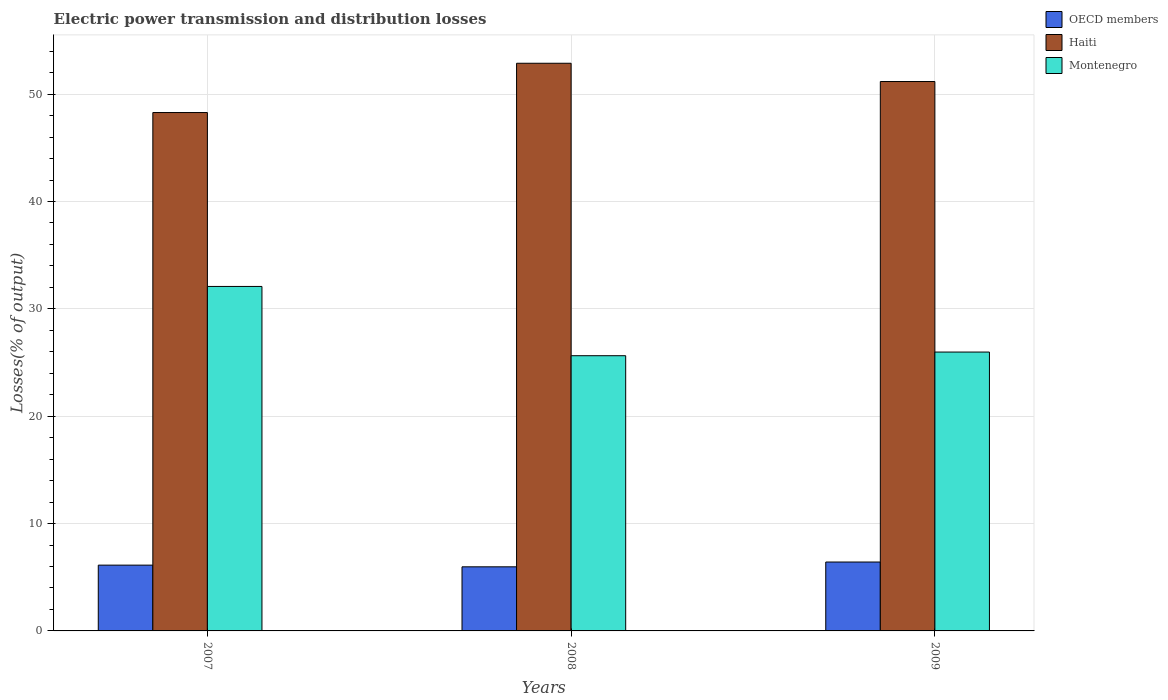How many different coloured bars are there?
Make the answer very short. 3. How many groups of bars are there?
Give a very brief answer. 3. Are the number of bars per tick equal to the number of legend labels?
Your answer should be very brief. Yes. How many bars are there on the 2nd tick from the right?
Provide a short and direct response. 3. What is the electric power transmission and distribution losses in OECD members in 2007?
Give a very brief answer. 6.13. Across all years, what is the maximum electric power transmission and distribution losses in OECD members?
Offer a very short reply. 6.42. Across all years, what is the minimum electric power transmission and distribution losses in Haiti?
Ensure brevity in your answer.  48.29. What is the total electric power transmission and distribution losses in OECD members in the graph?
Offer a terse response. 18.52. What is the difference between the electric power transmission and distribution losses in OECD members in 2007 and that in 2008?
Give a very brief answer. 0.16. What is the difference between the electric power transmission and distribution losses in OECD members in 2008 and the electric power transmission and distribution losses in Haiti in 2007?
Give a very brief answer. -42.32. What is the average electric power transmission and distribution losses in OECD members per year?
Offer a very short reply. 6.17. In the year 2007, what is the difference between the electric power transmission and distribution losses in Haiti and electric power transmission and distribution losses in Montenegro?
Offer a very short reply. 16.2. What is the ratio of the electric power transmission and distribution losses in OECD members in 2007 to that in 2008?
Offer a terse response. 1.03. Is the electric power transmission and distribution losses in Montenegro in 2008 less than that in 2009?
Give a very brief answer. Yes. Is the difference between the electric power transmission and distribution losses in Haiti in 2007 and 2008 greater than the difference between the electric power transmission and distribution losses in Montenegro in 2007 and 2008?
Your answer should be very brief. No. What is the difference between the highest and the second highest electric power transmission and distribution losses in Haiti?
Provide a succinct answer. 1.7. What is the difference between the highest and the lowest electric power transmission and distribution losses in Haiti?
Provide a succinct answer. 4.59. In how many years, is the electric power transmission and distribution losses in Haiti greater than the average electric power transmission and distribution losses in Haiti taken over all years?
Make the answer very short. 2. What does the 1st bar from the left in 2007 represents?
Offer a very short reply. OECD members. What does the 2nd bar from the right in 2007 represents?
Give a very brief answer. Haiti. Is it the case that in every year, the sum of the electric power transmission and distribution losses in Haiti and electric power transmission and distribution losses in OECD members is greater than the electric power transmission and distribution losses in Montenegro?
Your response must be concise. Yes. How many bars are there?
Your answer should be compact. 9. Are all the bars in the graph horizontal?
Ensure brevity in your answer.  No. What is the difference between two consecutive major ticks on the Y-axis?
Your response must be concise. 10. Are the values on the major ticks of Y-axis written in scientific E-notation?
Your answer should be very brief. No. Does the graph contain any zero values?
Provide a short and direct response. No. Does the graph contain grids?
Offer a terse response. Yes. How are the legend labels stacked?
Keep it short and to the point. Vertical. What is the title of the graph?
Your response must be concise. Electric power transmission and distribution losses. Does "Gambia, The" appear as one of the legend labels in the graph?
Your answer should be compact. No. What is the label or title of the X-axis?
Provide a short and direct response. Years. What is the label or title of the Y-axis?
Give a very brief answer. Losses(% of output). What is the Losses(% of output) of OECD members in 2007?
Your answer should be compact. 6.13. What is the Losses(% of output) in Haiti in 2007?
Offer a very short reply. 48.29. What is the Losses(% of output) in Montenegro in 2007?
Offer a very short reply. 32.09. What is the Losses(% of output) of OECD members in 2008?
Offer a very short reply. 5.97. What is the Losses(% of output) in Haiti in 2008?
Ensure brevity in your answer.  52.88. What is the Losses(% of output) of Montenegro in 2008?
Your answer should be compact. 25.64. What is the Losses(% of output) in OECD members in 2009?
Your answer should be compact. 6.42. What is the Losses(% of output) of Haiti in 2009?
Provide a short and direct response. 51.18. What is the Losses(% of output) of Montenegro in 2009?
Offer a terse response. 25.98. Across all years, what is the maximum Losses(% of output) of OECD members?
Your answer should be very brief. 6.42. Across all years, what is the maximum Losses(% of output) in Haiti?
Give a very brief answer. 52.88. Across all years, what is the maximum Losses(% of output) in Montenegro?
Your answer should be very brief. 32.09. Across all years, what is the minimum Losses(% of output) in OECD members?
Offer a very short reply. 5.97. Across all years, what is the minimum Losses(% of output) in Haiti?
Your response must be concise. 48.29. Across all years, what is the minimum Losses(% of output) of Montenegro?
Offer a very short reply. 25.64. What is the total Losses(% of output) in OECD members in the graph?
Offer a terse response. 18.52. What is the total Losses(% of output) in Haiti in the graph?
Give a very brief answer. 152.35. What is the total Losses(% of output) in Montenegro in the graph?
Your answer should be very brief. 83.7. What is the difference between the Losses(% of output) of OECD members in 2007 and that in 2008?
Provide a short and direct response. 0.16. What is the difference between the Losses(% of output) of Haiti in 2007 and that in 2008?
Offer a very short reply. -4.59. What is the difference between the Losses(% of output) of Montenegro in 2007 and that in 2008?
Provide a short and direct response. 6.45. What is the difference between the Losses(% of output) of OECD members in 2007 and that in 2009?
Offer a very short reply. -0.29. What is the difference between the Losses(% of output) in Haiti in 2007 and that in 2009?
Keep it short and to the point. -2.89. What is the difference between the Losses(% of output) of Montenegro in 2007 and that in 2009?
Provide a short and direct response. 6.11. What is the difference between the Losses(% of output) of OECD members in 2008 and that in 2009?
Your answer should be very brief. -0.45. What is the difference between the Losses(% of output) in Haiti in 2008 and that in 2009?
Ensure brevity in your answer.  1.7. What is the difference between the Losses(% of output) in Montenegro in 2008 and that in 2009?
Offer a very short reply. -0.34. What is the difference between the Losses(% of output) of OECD members in 2007 and the Losses(% of output) of Haiti in 2008?
Give a very brief answer. -46.75. What is the difference between the Losses(% of output) in OECD members in 2007 and the Losses(% of output) in Montenegro in 2008?
Your answer should be very brief. -19.51. What is the difference between the Losses(% of output) in Haiti in 2007 and the Losses(% of output) in Montenegro in 2008?
Make the answer very short. 22.65. What is the difference between the Losses(% of output) of OECD members in 2007 and the Losses(% of output) of Haiti in 2009?
Ensure brevity in your answer.  -45.05. What is the difference between the Losses(% of output) in OECD members in 2007 and the Losses(% of output) in Montenegro in 2009?
Give a very brief answer. -19.85. What is the difference between the Losses(% of output) of Haiti in 2007 and the Losses(% of output) of Montenegro in 2009?
Your answer should be very brief. 22.31. What is the difference between the Losses(% of output) in OECD members in 2008 and the Losses(% of output) in Haiti in 2009?
Offer a terse response. -45.21. What is the difference between the Losses(% of output) in OECD members in 2008 and the Losses(% of output) in Montenegro in 2009?
Provide a short and direct response. -20.01. What is the difference between the Losses(% of output) of Haiti in 2008 and the Losses(% of output) of Montenegro in 2009?
Ensure brevity in your answer.  26.9. What is the average Losses(% of output) of OECD members per year?
Give a very brief answer. 6.17. What is the average Losses(% of output) of Haiti per year?
Ensure brevity in your answer.  50.78. What is the average Losses(% of output) of Montenegro per year?
Provide a short and direct response. 27.9. In the year 2007, what is the difference between the Losses(% of output) of OECD members and Losses(% of output) of Haiti?
Provide a short and direct response. -42.16. In the year 2007, what is the difference between the Losses(% of output) of OECD members and Losses(% of output) of Montenegro?
Offer a terse response. -25.96. In the year 2007, what is the difference between the Losses(% of output) of Haiti and Losses(% of output) of Montenegro?
Offer a terse response. 16.2. In the year 2008, what is the difference between the Losses(% of output) in OECD members and Losses(% of output) in Haiti?
Your response must be concise. -46.91. In the year 2008, what is the difference between the Losses(% of output) of OECD members and Losses(% of output) of Montenegro?
Keep it short and to the point. -19.66. In the year 2008, what is the difference between the Losses(% of output) of Haiti and Losses(% of output) of Montenegro?
Your response must be concise. 27.24. In the year 2009, what is the difference between the Losses(% of output) of OECD members and Losses(% of output) of Haiti?
Give a very brief answer. -44.76. In the year 2009, what is the difference between the Losses(% of output) of OECD members and Losses(% of output) of Montenegro?
Your response must be concise. -19.56. In the year 2009, what is the difference between the Losses(% of output) of Haiti and Losses(% of output) of Montenegro?
Make the answer very short. 25.2. What is the ratio of the Losses(% of output) of OECD members in 2007 to that in 2008?
Your answer should be compact. 1.03. What is the ratio of the Losses(% of output) in Haiti in 2007 to that in 2008?
Offer a terse response. 0.91. What is the ratio of the Losses(% of output) in Montenegro in 2007 to that in 2008?
Offer a terse response. 1.25. What is the ratio of the Losses(% of output) in OECD members in 2007 to that in 2009?
Provide a succinct answer. 0.95. What is the ratio of the Losses(% of output) in Haiti in 2007 to that in 2009?
Give a very brief answer. 0.94. What is the ratio of the Losses(% of output) in Montenegro in 2007 to that in 2009?
Your answer should be compact. 1.24. What is the ratio of the Losses(% of output) of OECD members in 2008 to that in 2009?
Keep it short and to the point. 0.93. What is the ratio of the Losses(% of output) in Montenegro in 2008 to that in 2009?
Your answer should be very brief. 0.99. What is the difference between the highest and the second highest Losses(% of output) of OECD members?
Make the answer very short. 0.29. What is the difference between the highest and the second highest Losses(% of output) in Haiti?
Your answer should be very brief. 1.7. What is the difference between the highest and the second highest Losses(% of output) of Montenegro?
Provide a short and direct response. 6.11. What is the difference between the highest and the lowest Losses(% of output) in OECD members?
Offer a terse response. 0.45. What is the difference between the highest and the lowest Losses(% of output) of Haiti?
Your answer should be very brief. 4.59. What is the difference between the highest and the lowest Losses(% of output) of Montenegro?
Your answer should be compact. 6.45. 